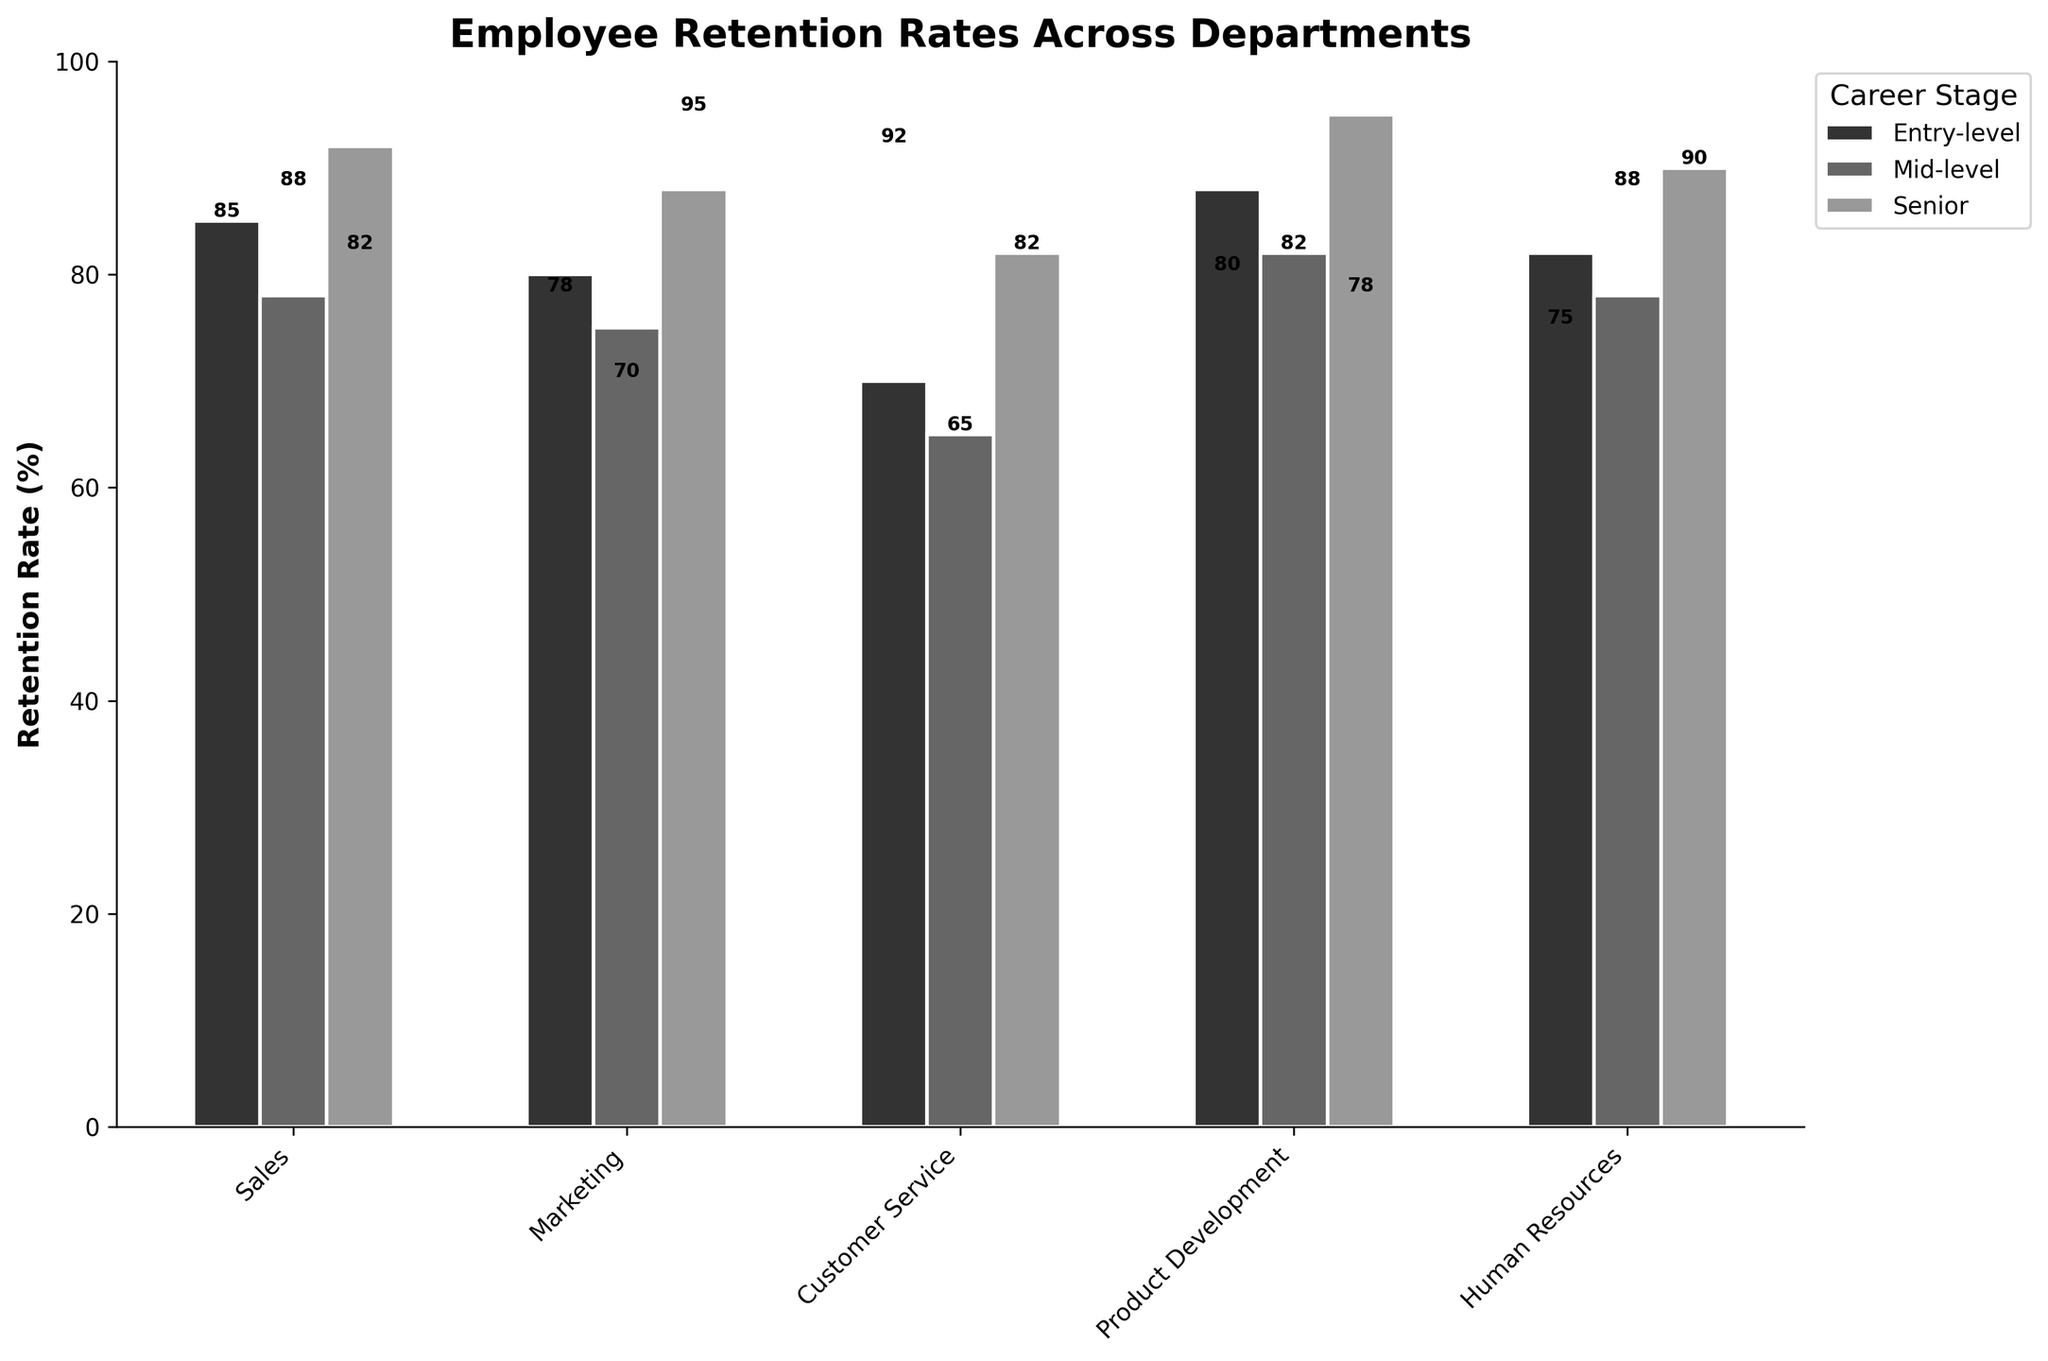What is the title of the plot? The title of the plot is located at the top and is in bold font. It reads, 'Employee Retention Rates Across Departments'.
Answer: Employee Retention Rates Across Departments What is the retention rate for Entry-level positions in Customer Service? Find the bar corresponding to Entry-level in the Customer Service category. The retention rate displayed above this bar is the required value.
Answer: 70 Which department has the highest retention rate at the Senior level? By examining the bars for Senior level across all departments, the highest bar corresponds to Product Development.
Answer: Product Development How does the retention rate in Entry-level positions of Product Development compare to that in Human Resources? Find the bars representing Entry-level positions in both Product Development and Human Resources. Product Development has a retention rate of 88%, while Human Resources has 82%.
Answer: Product Development is higher What is the average retention rate for Marketing across all career stages? Add the retention rates for all career stages in Marketing (80 + 75 + 88) and divide by the number of stages (3). (80 + 75 + 88) / 3 = 243 / 3.
Answer: 81 Which career stage in Sales has the lowest retention rate? Compare the bars within Sales; Entry-level is 85%, Mid-level is 78%, and Senior is 92%. The lowest is Mid-level.
Answer: Mid-level Is the retention rate for Mid-level employees in Customer Service greater than 60%? The retention rate for Mid-level in Customer Service is 65%, which is greater than 60%.
Answer: Yes What is the difference in retention rates between Senior and Mid-level positions in Human Resources? Senior is at 90% and Mid-level at 78%. Subtracting these gives 90 - 78.
Answer: 12 At which career stage does Marketing have the lowest retention rate? By comparing bars within Marketing, Entry-level is 80%, Mid-level is 75%, and Senior is 88%. The lowest is Mid-level.
Answer: Mid-level Across all departments, which career stage generally has the highest retention rates? Looking at each department, Senior level tends to have the highest retention rates: Sales (92%), Marketing (88%), Customer Service (82%), Product Development (95%), Human Resources (90%).
Answer: Senior 